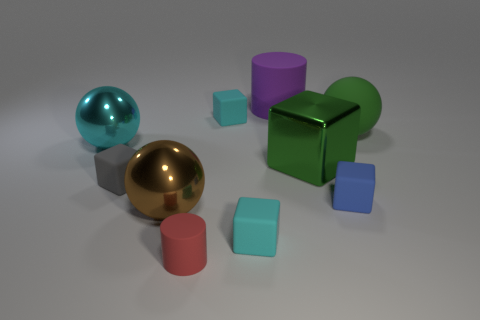Are there fewer tiny green matte cubes than large purple rubber cylinders?
Provide a short and direct response. Yes. What number of other things are the same color as the large metal block?
Your answer should be compact. 1. What number of tiny gray cubes are there?
Your response must be concise. 1. Are there fewer big green spheres to the left of the big green block than tiny yellow matte balls?
Keep it short and to the point. No. Does the tiny cyan thing behind the big green rubber ball have the same material as the small blue cube?
Keep it short and to the point. Yes. There is a big metal thing that is to the right of the tiny cyan object in front of the sphere right of the small blue block; what is its shape?
Give a very brief answer. Cube. Are there any objects of the same size as the purple cylinder?
Make the answer very short. Yes. How big is the blue block?
Ensure brevity in your answer.  Small. What number of green rubber balls have the same size as the brown shiny sphere?
Your answer should be compact. 1. Are there fewer cyan things left of the cyan ball than small blue matte things in front of the tiny red rubber cylinder?
Your answer should be compact. No. 